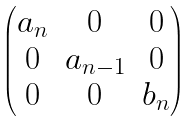Convert formula to latex. <formula><loc_0><loc_0><loc_500><loc_500>\begin{pmatrix} a _ { n } & 0 & 0 \\ 0 & a _ { n - 1 } & 0 \\ 0 & 0 & b _ { n } \end{pmatrix}</formula> 